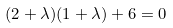Convert formula to latex. <formula><loc_0><loc_0><loc_500><loc_500>( 2 + \lambda ) ( 1 + \lambda ) + 6 = 0</formula> 